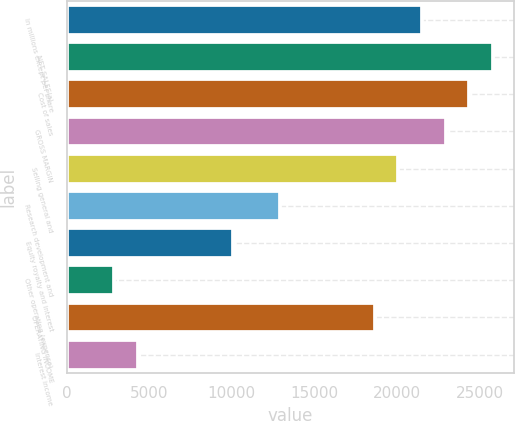<chart> <loc_0><loc_0><loc_500><loc_500><bar_chart><fcel>In millions except per share<fcel>NET SALES(a)<fcel>Cost of sales<fcel>GROSS MARGIN<fcel>Selling general and<fcel>Research development and<fcel>Equity royalty and interest<fcel>Other operating (expense)<fcel>OPERATING INCOME<fcel>Interest income<nl><fcel>21511.1<fcel>25812.6<fcel>24378.8<fcel>22945<fcel>20077.3<fcel>12908.2<fcel>10040.6<fcel>2871.48<fcel>18643.5<fcel>4305.3<nl></chart> 